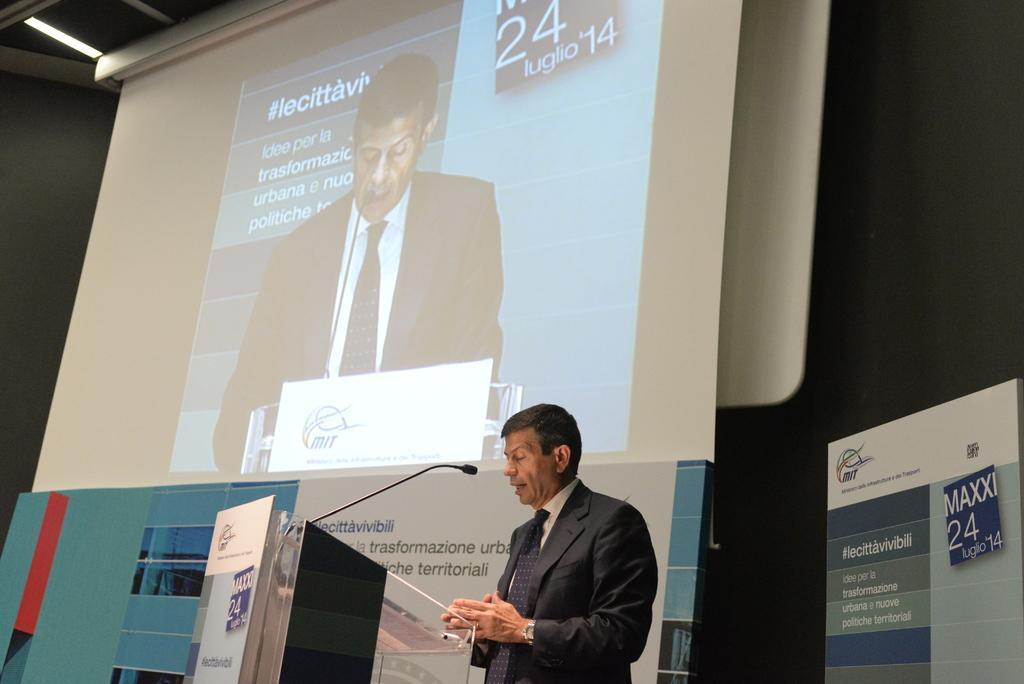Please provide a concise description of this image. In this image there is a man standing, in front of a podium on that podium there is a mic, in the background there is a screen on that there is projection, at the bottom there is poster on that poster is some text and in the bottom right there is poster on that poster there is some text. 